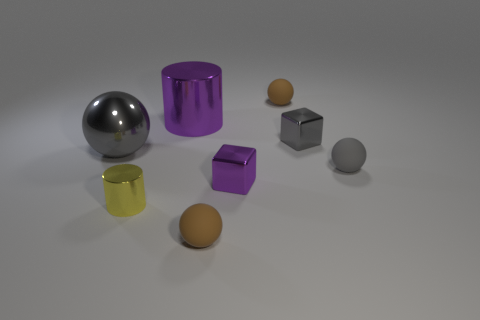Add 1 large red matte objects. How many objects exist? 9 Subtract all blocks. How many objects are left? 6 Subtract 0 red cubes. How many objects are left? 8 Subtract all tiny purple matte objects. Subtract all blocks. How many objects are left? 6 Add 4 tiny gray balls. How many tiny gray balls are left? 5 Add 5 balls. How many balls exist? 9 